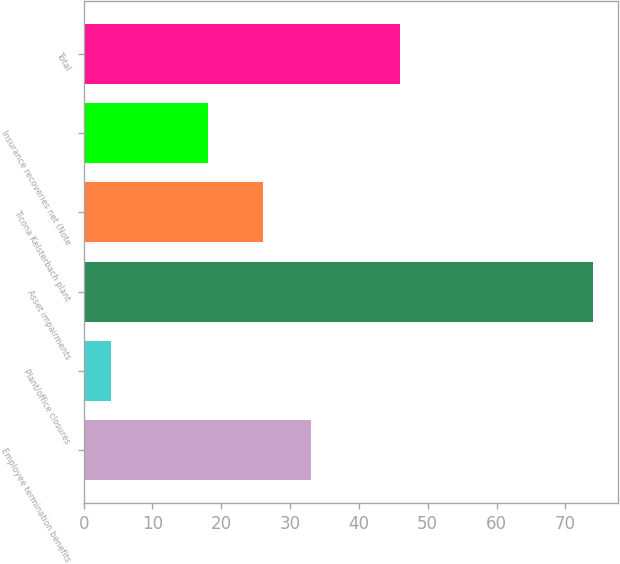<chart> <loc_0><loc_0><loc_500><loc_500><bar_chart><fcel>Employee termination benefits<fcel>Plant/office closures<fcel>Asset impairments<fcel>Ticona Kelsterbach plant<fcel>Insurance recoveries net (Note<fcel>Total<nl><fcel>33<fcel>4<fcel>74<fcel>26<fcel>18<fcel>46<nl></chart> 